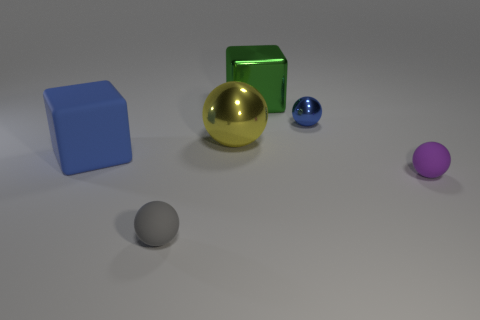There is a small rubber object to the left of the metallic sphere on the left side of the big shiny block; what is its shape?
Provide a succinct answer. Sphere. Are there more blue objects than small yellow balls?
Provide a succinct answer. Yes. How many things are both right of the blue cube and in front of the yellow sphere?
Provide a short and direct response. 2. How many green cubes are on the right side of the green cube that is behind the purple ball?
Ensure brevity in your answer.  0. How many objects are either rubber balls that are left of the blue ball or big objects behind the big blue rubber thing?
Give a very brief answer. 3. What is the material of the green thing that is the same shape as the big blue object?
Keep it short and to the point. Metal. What number of things are shiny spheres that are right of the green block or tiny blue metallic objects?
Your answer should be very brief. 1. There is a big green object that is made of the same material as the big yellow object; what is its shape?
Offer a terse response. Cube. How many yellow metallic things have the same shape as the green shiny thing?
Provide a short and direct response. 0. What is the material of the big ball?
Provide a short and direct response. Metal. 